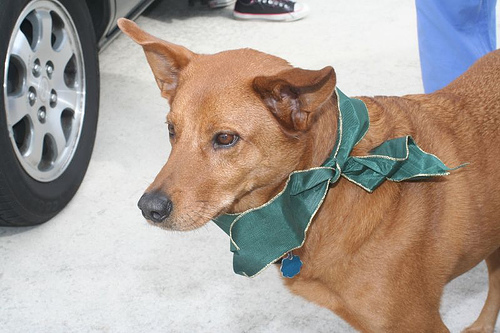<image>
Is there a ribbon on the dog? Yes. Looking at the image, I can see the ribbon is positioned on top of the dog, with the dog providing support. Is the dog to the left of the ribbon? No. The dog is not to the left of the ribbon. From this viewpoint, they have a different horizontal relationship. 